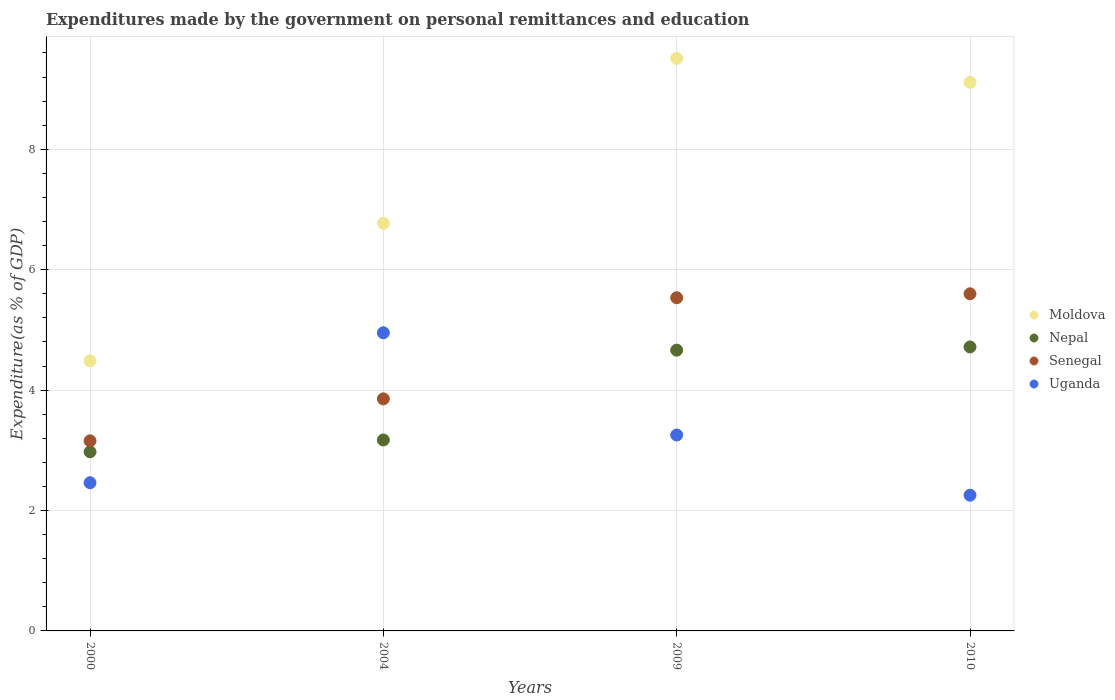How many different coloured dotlines are there?
Make the answer very short. 4. Is the number of dotlines equal to the number of legend labels?
Your response must be concise. Yes. What is the expenditures made by the government on personal remittances and education in Uganda in 2009?
Your answer should be very brief. 3.25. Across all years, what is the maximum expenditures made by the government on personal remittances and education in Uganda?
Keep it short and to the point. 4.95. Across all years, what is the minimum expenditures made by the government on personal remittances and education in Uganda?
Ensure brevity in your answer.  2.25. In which year was the expenditures made by the government on personal remittances and education in Nepal maximum?
Your answer should be very brief. 2010. What is the total expenditures made by the government on personal remittances and education in Uganda in the graph?
Make the answer very short. 12.92. What is the difference between the expenditures made by the government on personal remittances and education in Nepal in 2009 and that in 2010?
Offer a terse response. -0.05. What is the difference between the expenditures made by the government on personal remittances and education in Moldova in 2000 and the expenditures made by the government on personal remittances and education in Nepal in 2010?
Make the answer very short. -0.23. What is the average expenditures made by the government on personal remittances and education in Moldova per year?
Ensure brevity in your answer.  7.47. In the year 2004, what is the difference between the expenditures made by the government on personal remittances and education in Senegal and expenditures made by the government on personal remittances and education in Moldova?
Your answer should be compact. -2.92. What is the ratio of the expenditures made by the government on personal remittances and education in Uganda in 2009 to that in 2010?
Give a very brief answer. 1.44. Is the expenditures made by the government on personal remittances and education in Nepal in 2000 less than that in 2009?
Provide a succinct answer. Yes. Is the difference between the expenditures made by the government on personal remittances and education in Senegal in 2000 and 2004 greater than the difference between the expenditures made by the government on personal remittances and education in Moldova in 2000 and 2004?
Make the answer very short. Yes. What is the difference between the highest and the second highest expenditures made by the government on personal remittances and education in Nepal?
Your answer should be very brief. 0.05. What is the difference between the highest and the lowest expenditures made by the government on personal remittances and education in Senegal?
Provide a succinct answer. 2.44. In how many years, is the expenditures made by the government on personal remittances and education in Moldova greater than the average expenditures made by the government on personal remittances and education in Moldova taken over all years?
Your answer should be compact. 2. Is it the case that in every year, the sum of the expenditures made by the government on personal remittances and education in Nepal and expenditures made by the government on personal remittances and education in Senegal  is greater than the sum of expenditures made by the government on personal remittances and education in Moldova and expenditures made by the government on personal remittances and education in Uganda?
Ensure brevity in your answer.  No. Is it the case that in every year, the sum of the expenditures made by the government on personal remittances and education in Senegal and expenditures made by the government on personal remittances and education in Nepal  is greater than the expenditures made by the government on personal remittances and education in Uganda?
Ensure brevity in your answer.  Yes. Does the expenditures made by the government on personal remittances and education in Senegal monotonically increase over the years?
Your answer should be very brief. Yes. How many dotlines are there?
Give a very brief answer. 4. How many years are there in the graph?
Keep it short and to the point. 4. What is the difference between two consecutive major ticks on the Y-axis?
Offer a terse response. 2. Does the graph contain any zero values?
Keep it short and to the point. No. Where does the legend appear in the graph?
Offer a very short reply. Center right. How are the legend labels stacked?
Your response must be concise. Vertical. What is the title of the graph?
Offer a very short reply. Expenditures made by the government on personal remittances and education. What is the label or title of the Y-axis?
Offer a terse response. Expenditure(as % of GDP). What is the Expenditure(as % of GDP) in Moldova in 2000?
Your answer should be compact. 4.49. What is the Expenditure(as % of GDP) of Nepal in 2000?
Ensure brevity in your answer.  2.98. What is the Expenditure(as % of GDP) in Senegal in 2000?
Make the answer very short. 3.16. What is the Expenditure(as % of GDP) in Uganda in 2000?
Provide a succinct answer. 2.46. What is the Expenditure(as % of GDP) in Moldova in 2004?
Give a very brief answer. 6.77. What is the Expenditure(as % of GDP) of Nepal in 2004?
Your response must be concise. 3.17. What is the Expenditure(as % of GDP) of Senegal in 2004?
Ensure brevity in your answer.  3.85. What is the Expenditure(as % of GDP) of Uganda in 2004?
Make the answer very short. 4.95. What is the Expenditure(as % of GDP) in Moldova in 2009?
Keep it short and to the point. 9.51. What is the Expenditure(as % of GDP) in Nepal in 2009?
Ensure brevity in your answer.  4.66. What is the Expenditure(as % of GDP) of Senegal in 2009?
Provide a short and direct response. 5.53. What is the Expenditure(as % of GDP) in Uganda in 2009?
Your answer should be very brief. 3.25. What is the Expenditure(as % of GDP) in Moldova in 2010?
Your answer should be compact. 9.11. What is the Expenditure(as % of GDP) of Nepal in 2010?
Your response must be concise. 4.72. What is the Expenditure(as % of GDP) of Senegal in 2010?
Keep it short and to the point. 5.6. What is the Expenditure(as % of GDP) in Uganda in 2010?
Give a very brief answer. 2.25. Across all years, what is the maximum Expenditure(as % of GDP) in Moldova?
Provide a short and direct response. 9.51. Across all years, what is the maximum Expenditure(as % of GDP) in Nepal?
Your answer should be compact. 4.72. Across all years, what is the maximum Expenditure(as % of GDP) in Senegal?
Provide a short and direct response. 5.6. Across all years, what is the maximum Expenditure(as % of GDP) in Uganda?
Offer a very short reply. 4.95. Across all years, what is the minimum Expenditure(as % of GDP) of Moldova?
Make the answer very short. 4.49. Across all years, what is the minimum Expenditure(as % of GDP) in Nepal?
Offer a terse response. 2.98. Across all years, what is the minimum Expenditure(as % of GDP) of Senegal?
Your response must be concise. 3.16. Across all years, what is the minimum Expenditure(as % of GDP) of Uganda?
Your answer should be compact. 2.25. What is the total Expenditure(as % of GDP) in Moldova in the graph?
Your answer should be compact. 29.88. What is the total Expenditure(as % of GDP) in Nepal in the graph?
Give a very brief answer. 15.53. What is the total Expenditure(as % of GDP) of Senegal in the graph?
Offer a very short reply. 18.15. What is the total Expenditure(as % of GDP) of Uganda in the graph?
Offer a very short reply. 12.92. What is the difference between the Expenditure(as % of GDP) of Moldova in 2000 and that in 2004?
Provide a short and direct response. -2.28. What is the difference between the Expenditure(as % of GDP) in Nepal in 2000 and that in 2004?
Keep it short and to the point. -0.2. What is the difference between the Expenditure(as % of GDP) of Senegal in 2000 and that in 2004?
Offer a very short reply. -0.7. What is the difference between the Expenditure(as % of GDP) of Uganda in 2000 and that in 2004?
Keep it short and to the point. -2.49. What is the difference between the Expenditure(as % of GDP) of Moldova in 2000 and that in 2009?
Keep it short and to the point. -5.02. What is the difference between the Expenditure(as % of GDP) of Nepal in 2000 and that in 2009?
Your answer should be compact. -1.69. What is the difference between the Expenditure(as % of GDP) in Senegal in 2000 and that in 2009?
Your answer should be compact. -2.38. What is the difference between the Expenditure(as % of GDP) in Uganda in 2000 and that in 2009?
Keep it short and to the point. -0.79. What is the difference between the Expenditure(as % of GDP) of Moldova in 2000 and that in 2010?
Provide a succinct answer. -4.63. What is the difference between the Expenditure(as % of GDP) in Nepal in 2000 and that in 2010?
Offer a very short reply. -1.74. What is the difference between the Expenditure(as % of GDP) in Senegal in 2000 and that in 2010?
Make the answer very short. -2.44. What is the difference between the Expenditure(as % of GDP) of Uganda in 2000 and that in 2010?
Provide a succinct answer. 0.21. What is the difference between the Expenditure(as % of GDP) in Moldova in 2004 and that in 2009?
Give a very brief answer. -2.74. What is the difference between the Expenditure(as % of GDP) of Nepal in 2004 and that in 2009?
Your answer should be very brief. -1.49. What is the difference between the Expenditure(as % of GDP) of Senegal in 2004 and that in 2009?
Your answer should be compact. -1.68. What is the difference between the Expenditure(as % of GDP) of Uganda in 2004 and that in 2009?
Your answer should be very brief. 1.7. What is the difference between the Expenditure(as % of GDP) in Moldova in 2004 and that in 2010?
Your answer should be compact. -2.34. What is the difference between the Expenditure(as % of GDP) in Nepal in 2004 and that in 2010?
Ensure brevity in your answer.  -1.54. What is the difference between the Expenditure(as % of GDP) in Senegal in 2004 and that in 2010?
Your answer should be very brief. -1.75. What is the difference between the Expenditure(as % of GDP) of Uganda in 2004 and that in 2010?
Your answer should be very brief. 2.7. What is the difference between the Expenditure(as % of GDP) of Moldova in 2009 and that in 2010?
Offer a very short reply. 0.4. What is the difference between the Expenditure(as % of GDP) of Nepal in 2009 and that in 2010?
Make the answer very short. -0.05. What is the difference between the Expenditure(as % of GDP) in Senegal in 2009 and that in 2010?
Ensure brevity in your answer.  -0.07. What is the difference between the Expenditure(as % of GDP) in Uganda in 2009 and that in 2010?
Offer a terse response. 1. What is the difference between the Expenditure(as % of GDP) of Moldova in 2000 and the Expenditure(as % of GDP) of Nepal in 2004?
Ensure brevity in your answer.  1.31. What is the difference between the Expenditure(as % of GDP) of Moldova in 2000 and the Expenditure(as % of GDP) of Senegal in 2004?
Offer a very short reply. 0.63. What is the difference between the Expenditure(as % of GDP) in Moldova in 2000 and the Expenditure(as % of GDP) in Uganda in 2004?
Your response must be concise. -0.47. What is the difference between the Expenditure(as % of GDP) of Nepal in 2000 and the Expenditure(as % of GDP) of Senegal in 2004?
Your answer should be compact. -0.88. What is the difference between the Expenditure(as % of GDP) in Nepal in 2000 and the Expenditure(as % of GDP) in Uganda in 2004?
Provide a succinct answer. -1.98. What is the difference between the Expenditure(as % of GDP) of Senegal in 2000 and the Expenditure(as % of GDP) of Uganda in 2004?
Provide a succinct answer. -1.79. What is the difference between the Expenditure(as % of GDP) of Moldova in 2000 and the Expenditure(as % of GDP) of Nepal in 2009?
Ensure brevity in your answer.  -0.18. What is the difference between the Expenditure(as % of GDP) in Moldova in 2000 and the Expenditure(as % of GDP) in Senegal in 2009?
Make the answer very short. -1.05. What is the difference between the Expenditure(as % of GDP) in Moldova in 2000 and the Expenditure(as % of GDP) in Uganda in 2009?
Provide a succinct answer. 1.23. What is the difference between the Expenditure(as % of GDP) in Nepal in 2000 and the Expenditure(as % of GDP) in Senegal in 2009?
Your response must be concise. -2.56. What is the difference between the Expenditure(as % of GDP) of Nepal in 2000 and the Expenditure(as % of GDP) of Uganda in 2009?
Make the answer very short. -0.28. What is the difference between the Expenditure(as % of GDP) in Senegal in 2000 and the Expenditure(as % of GDP) in Uganda in 2009?
Offer a terse response. -0.1. What is the difference between the Expenditure(as % of GDP) in Moldova in 2000 and the Expenditure(as % of GDP) in Nepal in 2010?
Your response must be concise. -0.23. What is the difference between the Expenditure(as % of GDP) in Moldova in 2000 and the Expenditure(as % of GDP) in Senegal in 2010?
Ensure brevity in your answer.  -1.11. What is the difference between the Expenditure(as % of GDP) of Moldova in 2000 and the Expenditure(as % of GDP) of Uganda in 2010?
Your answer should be compact. 2.23. What is the difference between the Expenditure(as % of GDP) of Nepal in 2000 and the Expenditure(as % of GDP) of Senegal in 2010?
Provide a succinct answer. -2.62. What is the difference between the Expenditure(as % of GDP) of Nepal in 2000 and the Expenditure(as % of GDP) of Uganda in 2010?
Your answer should be very brief. 0.72. What is the difference between the Expenditure(as % of GDP) of Senegal in 2000 and the Expenditure(as % of GDP) of Uganda in 2010?
Provide a succinct answer. 0.9. What is the difference between the Expenditure(as % of GDP) in Moldova in 2004 and the Expenditure(as % of GDP) in Nepal in 2009?
Offer a terse response. 2.11. What is the difference between the Expenditure(as % of GDP) of Moldova in 2004 and the Expenditure(as % of GDP) of Senegal in 2009?
Ensure brevity in your answer.  1.24. What is the difference between the Expenditure(as % of GDP) of Moldova in 2004 and the Expenditure(as % of GDP) of Uganda in 2009?
Provide a succinct answer. 3.52. What is the difference between the Expenditure(as % of GDP) in Nepal in 2004 and the Expenditure(as % of GDP) in Senegal in 2009?
Offer a very short reply. -2.36. What is the difference between the Expenditure(as % of GDP) of Nepal in 2004 and the Expenditure(as % of GDP) of Uganda in 2009?
Ensure brevity in your answer.  -0.08. What is the difference between the Expenditure(as % of GDP) in Senegal in 2004 and the Expenditure(as % of GDP) in Uganda in 2009?
Make the answer very short. 0.6. What is the difference between the Expenditure(as % of GDP) of Moldova in 2004 and the Expenditure(as % of GDP) of Nepal in 2010?
Your response must be concise. 2.05. What is the difference between the Expenditure(as % of GDP) in Moldova in 2004 and the Expenditure(as % of GDP) in Senegal in 2010?
Provide a short and direct response. 1.17. What is the difference between the Expenditure(as % of GDP) in Moldova in 2004 and the Expenditure(as % of GDP) in Uganda in 2010?
Ensure brevity in your answer.  4.52. What is the difference between the Expenditure(as % of GDP) of Nepal in 2004 and the Expenditure(as % of GDP) of Senegal in 2010?
Your response must be concise. -2.43. What is the difference between the Expenditure(as % of GDP) in Nepal in 2004 and the Expenditure(as % of GDP) in Uganda in 2010?
Offer a very short reply. 0.92. What is the difference between the Expenditure(as % of GDP) of Senegal in 2004 and the Expenditure(as % of GDP) of Uganda in 2010?
Make the answer very short. 1.6. What is the difference between the Expenditure(as % of GDP) in Moldova in 2009 and the Expenditure(as % of GDP) in Nepal in 2010?
Offer a very short reply. 4.79. What is the difference between the Expenditure(as % of GDP) in Moldova in 2009 and the Expenditure(as % of GDP) in Senegal in 2010?
Provide a short and direct response. 3.91. What is the difference between the Expenditure(as % of GDP) in Moldova in 2009 and the Expenditure(as % of GDP) in Uganda in 2010?
Ensure brevity in your answer.  7.26. What is the difference between the Expenditure(as % of GDP) in Nepal in 2009 and the Expenditure(as % of GDP) in Senegal in 2010?
Give a very brief answer. -0.94. What is the difference between the Expenditure(as % of GDP) of Nepal in 2009 and the Expenditure(as % of GDP) of Uganda in 2010?
Offer a terse response. 2.41. What is the difference between the Expenditure(as % of GDP) in Senegal in 2009 and the Expenditure(as % of GDP) in Uganda in 2010?
Keep it short and to the point. 3.28. What is the average Expenditure(as % of GDP) in Moldova per year?
Make the answer very short. 7.47. What is the average Expenditure(as % of GDP) of Nepal per year?
Make the answer very short. 3.88. What is the average Expenditure(as % of GDP) of Senegal per year?
Offer a terse response. 4.54. What is the average Expenditure(as % of GDP) in Uganda per year?
Offer a very short reply. 3.23. In the year 2000, what is the difference between the Expenditure(as % of GDP) in Moldova and Expenditure(as % of GDP) in Nepal?
Make the answer very short. 1.51. In the year 2000, what is the difference between the Expenditure(as % of GDP) in Moldova and Expenditure(as % of GDP) in Senegal?
Offer a terse response. 1.33. In the year 2000, what is the difference between the Expenditure(as % of GDP) in Moldova and Expenditure(as % of GDP) in Uganda?
Your answer should be very brief. 2.02. In the year 2000, what is the difference between the Expenditure(as % of GDP) in Nepal and Expenditure(as % of GDP) in Senegal?
Offer a very short reply. -0.18. In the year 2000, what is the difference between the Expenditure(as % of GDP) in Nepal and Expenditure(as % of GDP) in Uganda?
Offer a very short reply. 0.51. In the year 2000, what is the difference between the Expenditure(as % of GDP) in Senegal and Expenditure(as % of GDP) in Uganda?
Offer a very short reply. 0.7. In the year 2004, what is the difference between the Expenditure(as % of GDP) in Moldova and Expenditure(as % of GDP) in Nepal?
Give a very brief answer. 3.6. In the year 2004, what is the difference between the Expenditure(as % of GDP) in Moldova and Expenditure(as % of GDP) in Senegal?
Provide a succinct answer. 2.92. In the year 2004, what is the difference between the Expenditure(as % of GDP) in Moldova and Expenditure(as % of GDP) in Uganda?
Offer a very short reply. 1.82. In the year 2004, what is the difference between the Expenditure(as % of GDP) in Nepal and Expenditure(as % of GDP) in Senegal?
Offer a terse response. -0.68. In the year 2004, what is the difference between the Expenditure(as % of GDP) of Nepal and Expenditure(as % of GDP) of Uganda?
Your answer should be compact. -1.78. In the year 2004, what is the difference between the Expenditure(as % of GDP) of Senegal and Expenditure(as % of GDP) of Uganda?
Your answer should be very brief. -1.1. In the year 2009, what is the difference between the Expenditure(as % of GDP) of Moldova and Expenditure(as % of GDP) of Nepal?
Give a very brief answer. 4.85. In the year 2009, what is the difference between the Expenditure(as % of GDP) of Moldova and Expenditure(as % of GDP) of Senegal?
Make the answer very short. 3.98. In the year 2009, what is the difference between the Expenditure(as % of GDP) in Moldova and Expenditure(as % of GDP) in Uganda?
Make the answer very short. 6.26. In the year 2009, what is the difference between the Expenditure(as % of GDP) of Nepal and Expenditure(as % of GDP) of Senegal?
Give a very brief answer. -0.87. In the year 2009, what is the difference between the Expenditure(as % of GDP) in Nepal and Expenditure(as % of GDP) in Uganda?
Keep it short and to the point. 1.41. In the year 2009, what is the difference between the Expenditure(as % of GDP) of Senegal and Expenditure(as % of GDP) of Uganda?
Make the answer very short. 2.28. In the year 2010, what is the difference between the Expenditure(as % of GDP) of Moldova and Expenditure(as % of GDP) of Nepal?
Give a very brief answer. 4.4. In the year 2010, what is the difference between the Expenditure(as % of GDP) of Moldova and Expenditure(as % of GDP) of Senegal?
Provide a short and direct response. 3.51. In the year 2010, what is the difference between the Expenditure(as % of GDP) in Moldova and Expenditure(as % of GDP) in Uganda?
Offer a very short reply. 6.86. In the year 2010, what is the difference between the Expenditure(as % of GDP) in Nepal and Expenditure(as % of GDP) in Senegal?
Offer a very short reply. -0.88. In the year 2010, what is the difference between the Expenditure(as % of GDP) of Nepal and Expenditure(as % of GDP) of Uganda?
Make the answer very short. 2.46. In the year 2010, what is the difference between the Expenditure(as % of GDP) of Senegal and Expenditure(as % of GDP) of Uganda?
Make the answer very short. 3.35. What is the ratio of the Expenditure(as % of GDP) of Moldova in 2000 to that in 2004?
Keep it short and to the point. 0.66. What is the ratio of the Expenditure(as % of GDP) in Nepal in 2000 to that in 2004?
Offer a terse response. 0.94. What is the ratio of the Expenditure(as % of GDP) of Senegal in 2000 to that in 2004?
Your answer should be compact. 0.82. What is the ratio of the Expenditure(as % of GDP) in Uganda in 2000 to that in 2004?
Offer a very short reply. 0.5. What is the ratio of the Expenditure(as % of GDP) in Moldova in 2000 to that in 2009?
Provide a succinct answer. 0.47. What is the ratio of the Expenditure(as % of GDP) of Nepal in 2000 to that in 2009?
Your response must be concise. 0.64. What is the ratio of the Expenditure(as % of GDP) in Senegal in 2000 to that in 2009?
Provide a short and direct response. 0.57. What is the ratio of the Expenditure(as % of GDP) in Uganda in 2000 to that in 2009?
Offer a terse response. 0.76. What is the ratio of the Expenditure(as % of GDP) of Moldova in 2000 to that in 2010?
Provide a succinct answer. 0.49. What is the ratio of the Expenditure(as % of GDP) of Nepal in 2000 to that in 2010?
Offer a very short reply. 0.63. What is the ratio of the Expenditure(as % of GDP) of Senegal in 2000 to that in 2010?
Provide a short and direct response. 0.56. What is the ratio of the Expenditure(as % of GDP) of Uganda in 2000 to that in 2010?
Give a very brief answer. 1.09. What is the ratio of the Expenditure(as % of GDP) in Moldova in 2004 to that in 2009?
Offer a very short reply. 0.71. What is the ratio of the Expenditure(as % of GDP) of Nepal in 2004 to that in 2009?
Provide a short and direct response. 0.68. What is the ratio of the Expenditure(as % of GDP) in Senegal in 2004 to that in 2009?
Your answer should be compact. 0.7. What is the ratio of the Expenditure(as % of GDP) in Uganda in 2004 to that in 2009?
Keep it short and to the point. 1.52. What is the ratio of the Expenditure(as % of GDP) of Moldova in 2004 to that in 2010?
Provide a succinct answer. 0.74. What is the ratio of the Expenditure(as % of GDP) in Nepal in 2004 to that in 2010?
Provide a succinct answer. 0.67. What is the ratio of the Expenditure(as % of GDP) of Senegal in 2004 to that in 2010?
Provide a short and direct response. 0.69. What is the ratio of the Expenditure(as % of GDP) in Uganda in 2004 to that in 2010?
Make the answer very short. 2.2. What is the ratio of the Expenditure(as % of GDP) of Moldova in 2009 to that in 2010?
Make the answer very short. 1.04. What is the ratio of the Expenditure(as % of GDP) in Nepal in 2009 to that in 2010?
Provide a succinct answer. 0.99. What is the ratio of the Expenditure(as % of GDP) in Senegal in 2009 to that in 2010?
Provide a succinct answer. 0.99. What is the ratio of the Expenditure(as % of GDP) in Uganda in 2009 to that in 2010?
Give a very brief answer. 1.44. What is the difference between the highest and the second highest Expenditure(as % of GDP) of Moldova?
Ensure brevity in your answer.  0.4. What is the difference between the highest and the second highest Expenditure(as % of GDP) of Nepal?
Your answer should be very brief. 0.05. What is the difference between the highest and the second highest Expenditure(as % of GDP) in Senegal?
Offer a terse response. 0.07. What is the difference between the highest and the second highest Expenditure(as % of GDP) in Uganda?
Keep it short and to the point. 1.7. What is the difference between the highest and the lowest Expenditure(as % of GDP) of Moldova?
Provide a succinct answer. 5.02. What is the difference between the highest and the lowest Expenditure(as % of GDP) in Nepal?
Ensure brevity in your answer.  1.74. What is the difference between the highest and the lowest Expenditure(as % of GDP) in Senegal?
Your answer should be compact. 2.44. What is the difference between the highest and the lowest Expenditure(as % of GDP) of Uganda?
Your answer should be very brief. 2.7. 